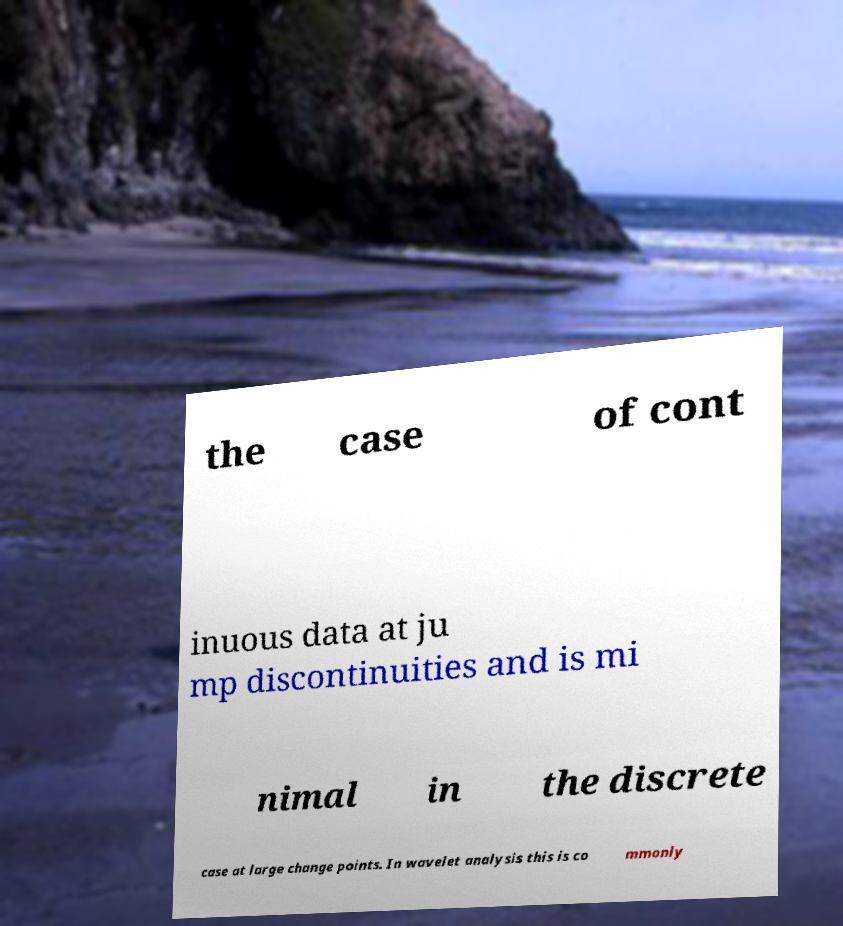What messages or text are displayed in this image? I need them in a readable, typed format. the case of cont inuous data at ju mp discontinuities and is mi nimal in the discrete case at large change points. In wavelet analysis this is co mmonly 